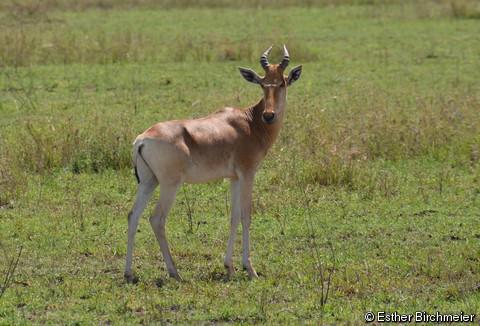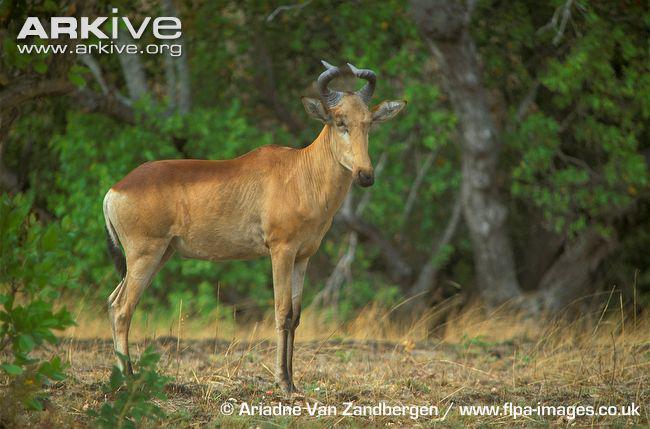The first image is the image on the left, the second image is the image on the right. For the images shown, is this caption "The left and right image contains the same number of elk walking right." true? Answer yes or no. Yes. 